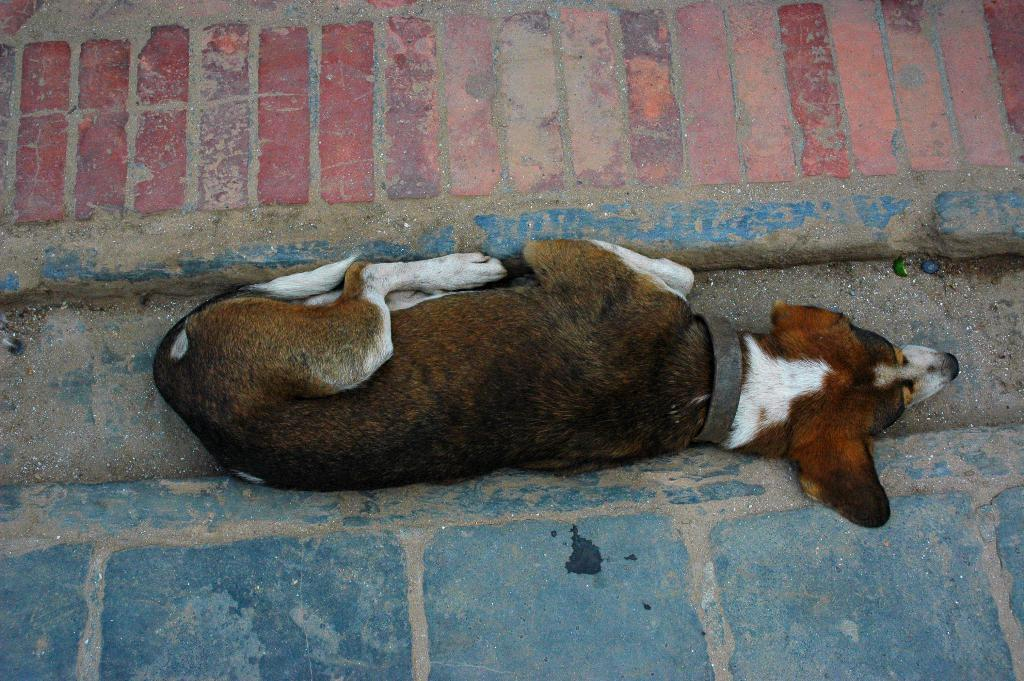What animal is present in the image? There is a dog in the image. Can you describe the position of the dog in the image? The dog is lying in the center of the image. What type of surface is visible in the background of the image? There is ground visible in the background of the image. What time is depicted in the image? The image does not depict a specific time; it is a still photograph. What type of vessel is present in the image? There is no vessel present in the image. Is there any smoke visible in the image? There is no smoke visible in the image. 